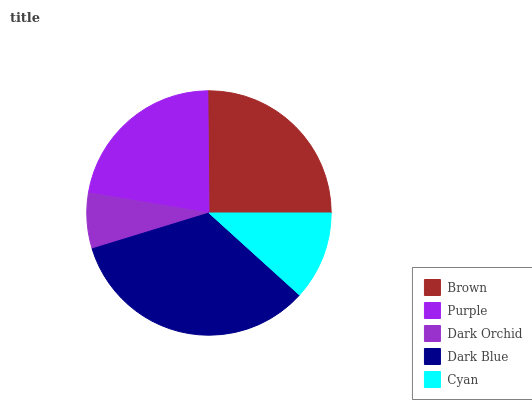Is Dark Orchid the minimum?
Answer yes or no. Yes. Is Dark Blue the maximum?
Answer yes or no. Yes. Is Purple the minimum?
Answer yes or no. No. Is Purple the maximum?
Answer yes or no. No. Is Brown greater than Purple?
Answer yes or no. Yes. Is Purple less than Brown?
Answer yes or no. Yes. Is Purple greater than Brown?
Answer yes or no. No. Is Brown less than Purple?
Answer yes or no. No. Is Purple the high median?
Answer yes or no. Yes. Is Purple the low median?
Answer yes or no. Yes. Is Dark Orchid the high median?
Answer yes or no. No. Is Cyan the low median?
Answer yes or no. No. 